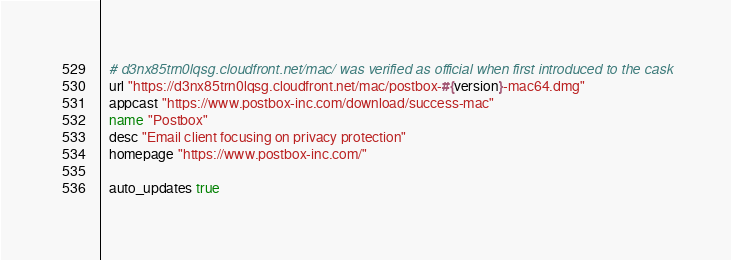<code> <loc_0><loc_0><loc_500><loc_500><_Ruby_>  # d3nx85trn0lqsg.cloudfront.net/mac/ was verified as official when first introduced to the cask
  url "https://d3nx85trn0lqsg.cloudfront.net/mac/postbox-#{version}-mac64.dmg"
  appcast "https://www.postbox-inc.com/download/success-mac"
  name "Postbox"
  desc "Email client focusing on privacy protection"
  homepage "https://www.postbox-inc.com/"

  auto_updates true</code> 